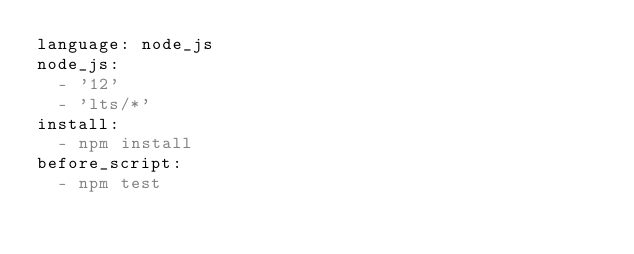<code> <loc_0><loc_0><loc_500><loc_500><_YAML_>language: node_js
node_js:
  - '12'
  - 'lts/*'
install:
  - npm install
before_script:
  - npm test
</code> 